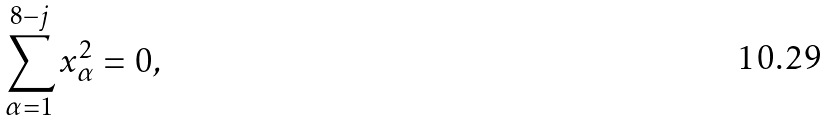<formula> <loc_0><loc_0><loc_500><loc_500>\sum _ { \alpha = 1 } ^ { 8 - j } x _ { \alpha } ^ { 2 } = 0 ,</formula> 